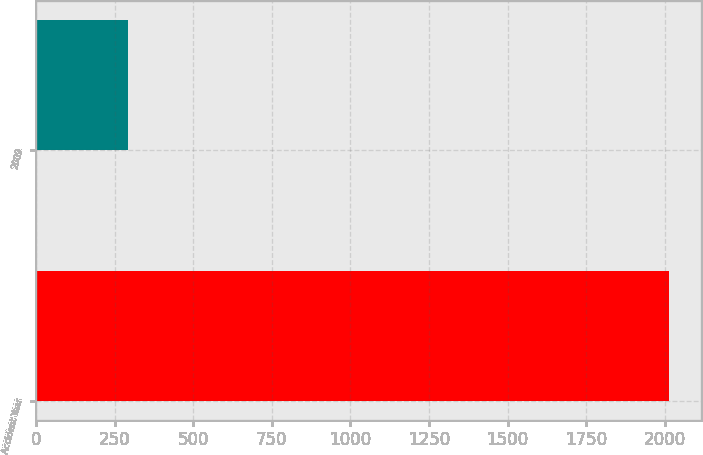Convert chart. <chart><loc_0><loc_0><loc_500><loc_500><bar_chart><fcel>Accident Year<fcel>2009<nl><fcel>2014<fcel>291<nl></chart> 